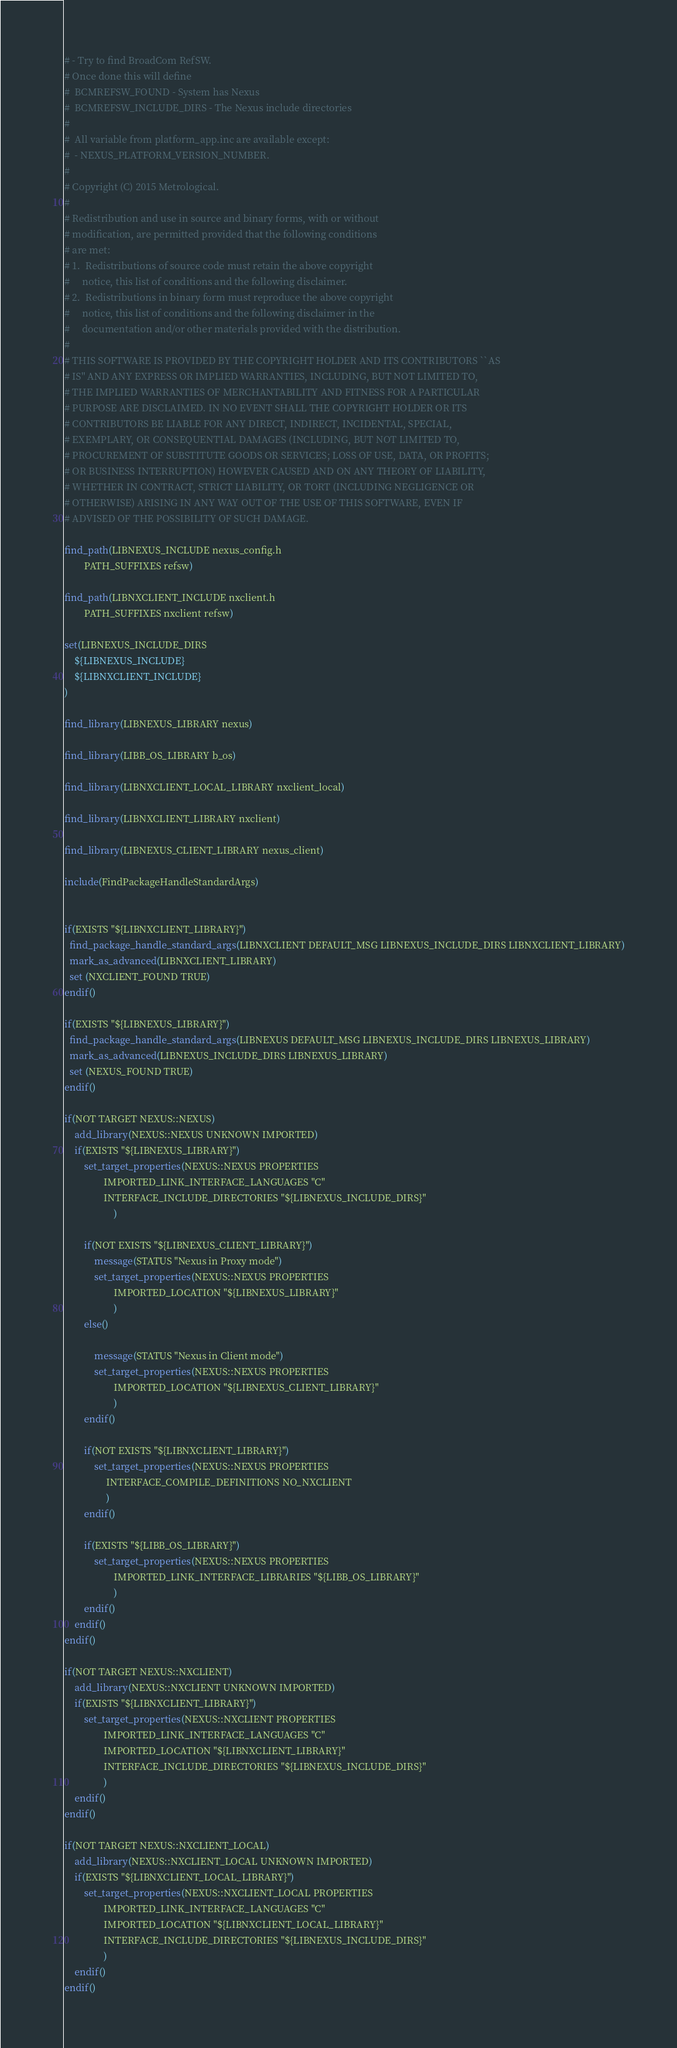<code> <loc_0><loc_0><loc_500><loc_500><_CMake_># - Try to find BroadCom RefSW.
# Once done this will define
#  BCMREFSW_FOUND - System has Nexus
#  BCMREFSW_INCLUDE_DIRS - The Nexus include directories
#
#  All variable from platform_app.inc are available except:
#  - NEXUS_PLATFORM_VERSION_NUMBER.
#
# Copyright (C) 2015 Metrological.
#
# Redistribution and use in source and binary forms, with or without
# modification, are permitted provided that the following conditions
# are met:
# 1.  Redistributions of source code must retain the above copyright
#     notice, this list of conditions and the following disclaimer.
# 2.  Redistributions in binary form must reproduce the above copyright
#     notice, this list of conditions and the following disclaimer in the
#     documentation and/or other materials provided with the distribution.
#
# THIS SOFTWARE IS PROVIDED BY THE COPYRIGHT HOLDER AND ITS CONTRIBUTORS ``AS
# IS'' AND ANY EXPRESS OR IMPLIED WARRANTIES, INCLUDING, BUT NOT LIMITED TO,
# THE IMPLIED WARRANTIES OF MERCHANTABILITY AND FITNESS FOR A PARTICULAR
# PURPOSE ARE DISCLAIMED. IN NO EVENT SHALL THE COPYRIGHT HOLDER OR ITS
# CONTRIBUTORS BE LIABLE FOR ANY DIRECT, INDIRECT, INCIDENTAL, SPECIAL,
# EXEMPLARY, OR CONSEQUENTIAL DAMAGES (INCLUDING, BUT NOT LIMITED TO,
# PROCUREMENT OF SUBSTITUTE GOODS OR SERVICES; LOSS OF USE, DATA, OR PROFITS;
# OR BUSINESS INTERRUPTION) HOWEVER CAUSED AND ON ANY THEORY OF LIABILITY,
# WHETHER IN CONTRACT, STRICT LIABILITY, OR TORT (INCLUDING NEGLIGENCE OR
# OTHERWISE) ARISING IN ANY WAY OUT OF THE USE OF THIS SOFTWARE, EVEN IF
# ADVISED OF THE POSSIBILITY OF SUCH DAMAGE.

find_path(LIBNEXUS_INCLUDE nexus_config.h
        PATH_SUFFIXES refsw)

find_path(LIBNXCLIENT_INCLUDE nxclient.h
        PATH_SUFFIXES nxclient refsw)

set(LIBNEXUS_INCLUDE_DIRS
    ${LIBNEXUS_INCLUDE}
    ${LIBNXCLIENT_INCLUDE}
)

find_library(LIBNEXUS_LIBRARY nexus)

find_library(LIBB_OS_LIBRARY b_os)

find_library(LIBNXCLIENT_LOCAL_LIBRARY nxclient_local)

find_library(LIBNXCLIENT_LIBRARY nxclient)

find_library(LIBNEXUS_CLIENT_LIBRARY nexus_client)

include(FindPackageHandleStandardArgs)


if(EXISTS "${LIBNXCLIENT_LIBRARY}")
  find_package_handle_standard_args(LIBNXCLIENT DEFAULT_MSG LIBNEXUS_INCLUDE_DIRS LIBNXCLIENT_LIBRARY)
  mark_as_advanced(LIBNXCLIENT_LIBRARY)
  set (NXCLIENT_FOUND TRUE)
endif()

if(EXISTS "${LIBNEXUS_LIBRARY}")
  find_package_handle_standard_args(LIBNEXUS DEFAULT_MSG LIBNEXUS_INCLUDE_DIRS LIBNEXUS_LIBRARY)
  mark_as_advanced(LIBNEXUS_INCLUDE_DIRS LIBNEXUS_LIBRARY)
  set (NEXUS_FOUND TRUE)
endif()

if(NOT TARGET NEXUS::NEXUS)
    add_library(NEXUS::NEXUS UNKNOWN IMPORTED)
    if(EXISTS "${LIBNEXUS_LIBRARY}")
        set_target_properties(NEXUS::NEXUS PROPERTIES
                IMPORTED_LINK_INTERFACE_LANGUAGES "C"
                INTERFACE_INCLUDE_DIRECTORIES "${LIBNEXUS_INCLUDE_DIRS}"
                    )

        if(NOT EXISTS "${LIBNEXUS_CLIENT_LIBRARY}")
            message(STATUS "Nexus in Proxy mode")
            set_target_properties(NEXUS::NEXUS PROPERTIES
                    IMPORTED_LOCATION "${LIBNEXUS_LIBRARY}"
                    )
        else()

            message(STATUS "Nexus in Client mode")
            set_target_properties(NEXUS::NEXUS PROPERTIES
                    IMPORTED_LOCATION "${LIBNEXUS_CLIENT_LIBRARY}"
                    )
        endif()

        if(NOT EXISTS "${LIBNXCLIENT_LIBRARY}")
            set_target_properties(NEXUS::NEXUS PROPERTIES
                 INTERFACE_COMPILE_DEFINITIONS NO_NXCLIENT
                 )
        endif()

        if(EXISTS "${LIBB_OS_LIBRARY}")
            set_target_properties(NEXUS::NEXUS PROPERTIES
                    IMPORTED_LINK_INTERFACE_LIBRARIES "${LIBB_OS_LIBRARY}"
                    )
        endif()
    endif()
endif()

if(NOT TARGET NEXUS::NXCLIENT)
    add_library(NEXUS::NXCLIENT UNKNOWN IMPORTED)
    if(EXISTS "${LIBNXCLIENT_LIBRARY}")
        set_target_properties(NEXUS::NXCLIENT PROPERTIES
                IMPORTED_LINK_INTERFACE_LANGUAGES "C"
                IMPORTED_LOCATION "${LIBNXCLIENT_LIBRARY}"
                INTERFACE_INCLUDE_DIRECTORIES "${LIBNEXUS_INCLUDE_DIRS}"
                )
    endif()
endif()

if(NOT TARGET NEXUS::NXCLIENT_LOCAL)
    add_library(NEXUS::NXCLIENT_LOCAL UNKNOWN IMPORTED)
    if(EXISTS "${LIBNXCLIENT_LOCAL_LIBRARY}")
        set_target_properties(NEXUS::NXCLIENT_LOCAL PROPERTIES
                IMPORTED_LINK_INTERFACE_LANGUAGES "C"
                IMPORTED_LOCATION "${LIBNXCLIENT_LOCAL_LIBRARY}"
                INTERFACE_INCLUDE_DIRECTORIES "${LIBNEXUS_INCLUDE_DIRS}"
                )
    endif()
endif()</code> 